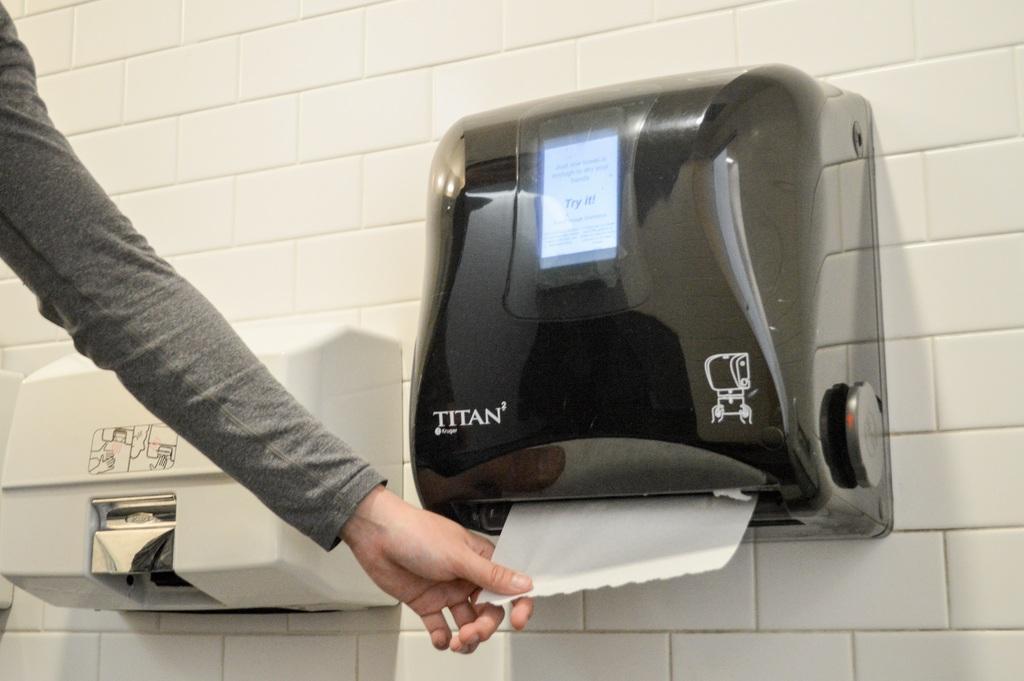In one or two sentences, can you explain what this image depicts? In the center of the image we can see a tissue holder and a dispenser placed on the wall. On the left we can see a person's hand holding a tissue. 